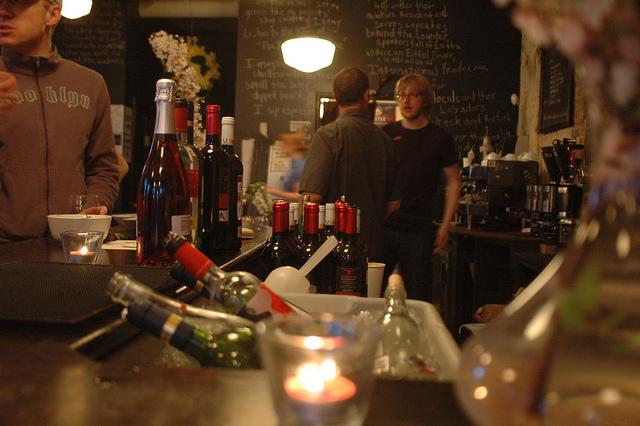Is there a bottle of champagne on the bar?
Answer briefly. Yes. Is the candle on the bar lit?
Keep it brief. Yes. What does the person on the lefts hoodie read?
Concise answer only. Brooklyn. 